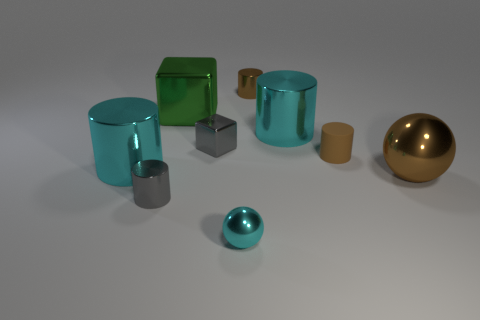Can you compare the sizes of the objects relative to each other? Certainly. In the image, we can observe a variety of object sizes. The green cube and the cyan and gold cylinders are the largest objects present. In contrast, the tiny cyan sphere and the gray metallic cylinder are the smallest. The golden sphere strikes a balance, being mid-sized when compared to the other objects. Overall, there is a diverse range of volumetric scales that add interest to the composition. 